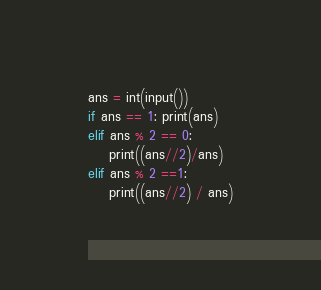<code> <loc_0><loc_0><loc_500><loc_500><_Python_>ans = int(input())
if ans == 1: print(ans)
elif ans % 2 == 0:
    print((ans//2)/ans)
elif ans % 2 ==1:
    print((ans//2) / ans)</code> 